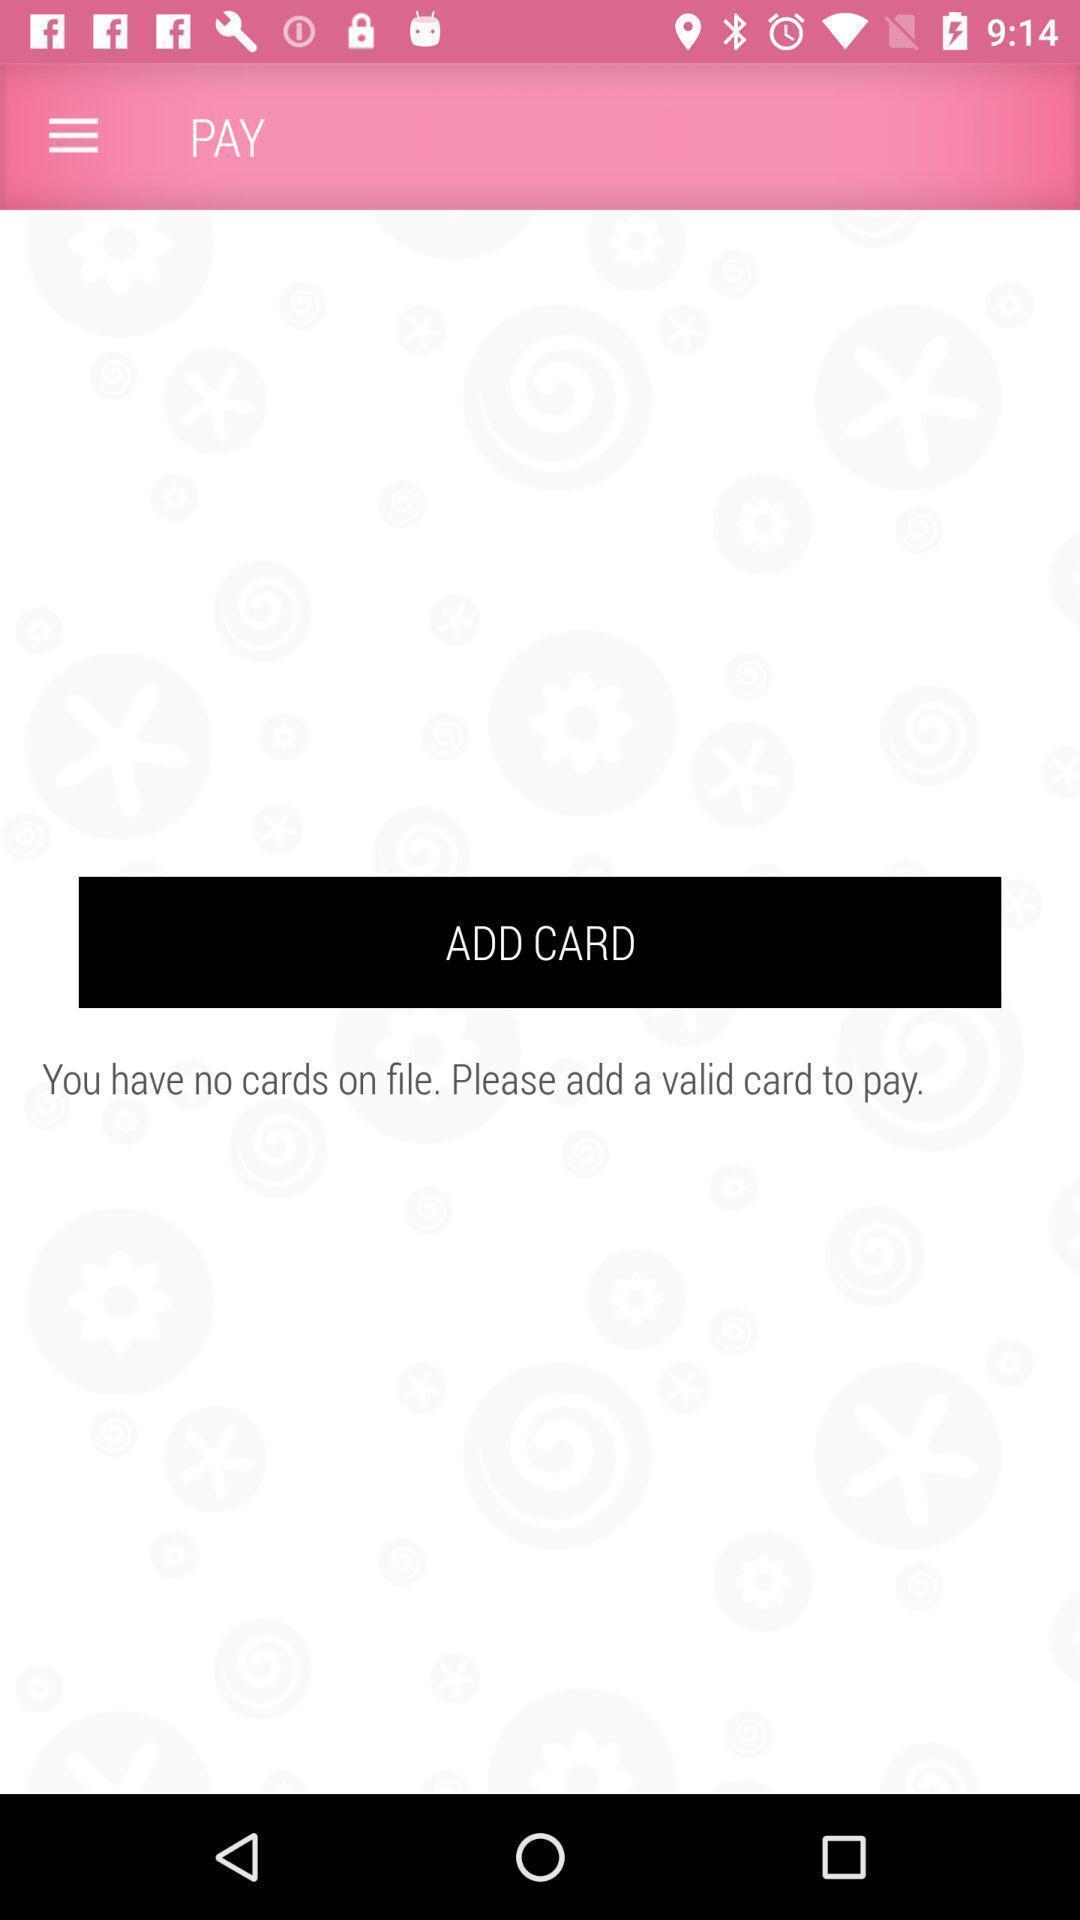What can you discern from this picture? Page shows to add card. 